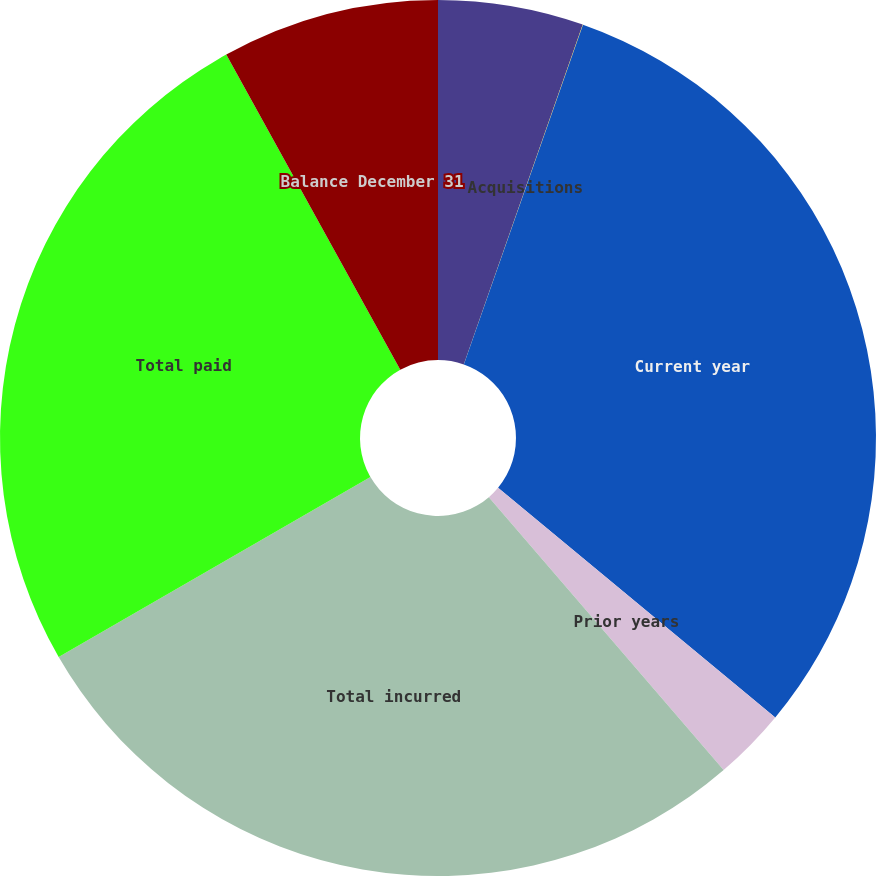Convert chart. <chart><loc_0><loc_0><loc_500><loc_500><pie_chart><fcel>Balance January 1<fcel>Acquisitions<fcel>Current year<fcel>Prior years<fcel>Total incurred<fcel>Total paid<fcel>Balance December 31<nl><fcel>5.36%<fcel>0.01%<fcel>30.64%<fcel>2.68%<fcel>27.97%<fcel>25.3%<fcel>8.03%<nl></chart> 